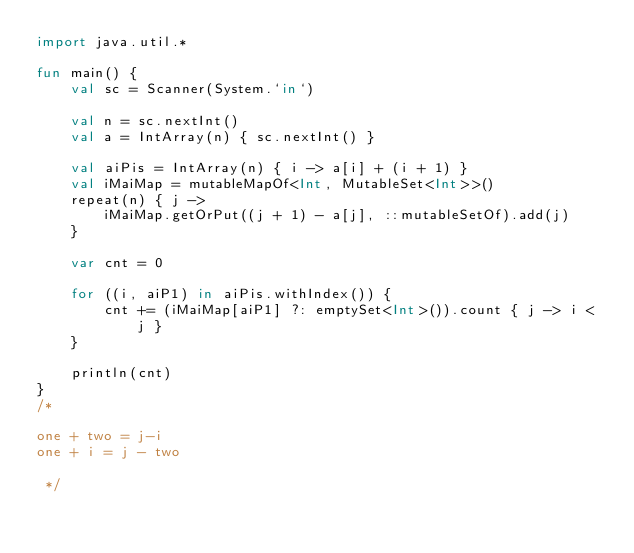Convert code to text. <code><loc_0><loc_0><loc_500><loc_500><_Kotlin_>import java.util.*

fun main() {
    val sc = Scanner(System.`in`)
    
    val n = sc.nextInt()
    val a = IntArray(n) { sc.nextInt() }

    val aiPis = IntArray(n) { i -> a[i] + (i + 1) }
    val iMaiMap = mutableMapOf<Int, MutableSet<Int>>()
    repeat(n) { j ->
        iMaiMap.getOrPut((j + 1) - a[j], ::mutableSetOf).add(j)
    }

    var cnt = 0

    for ((i, aiP1) in aiPis.withIndex()) {
        cnt += (iMaiMap[aiP1] ?: emptySet<Int>()).count { j -> i < j }
    }

    println(cnt)
}
/*

one + two = j-i
one + i = j - two

 */
</code> 